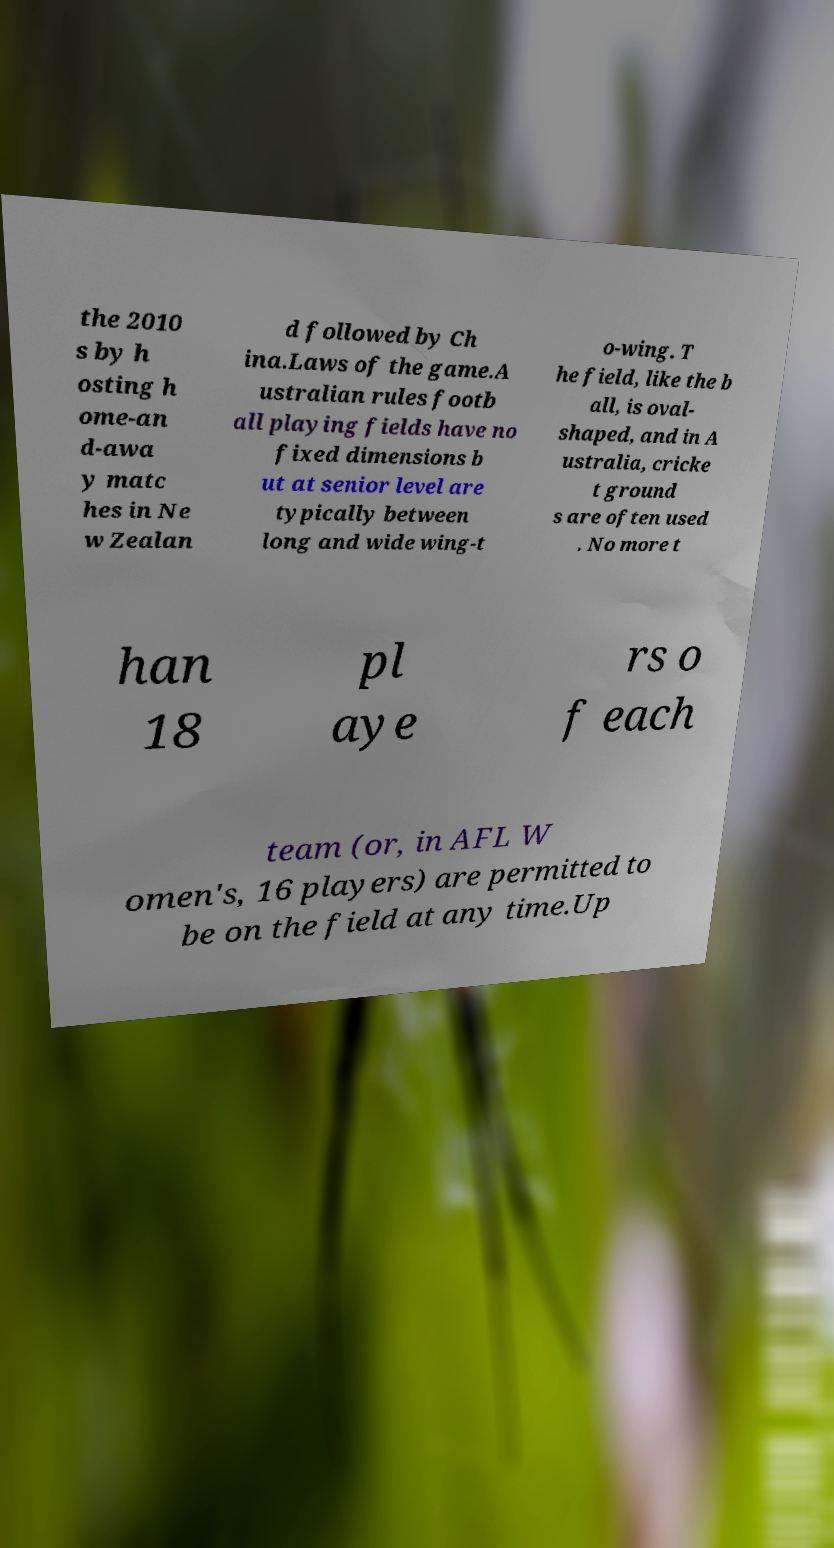Could you assist in decoding the text presented in this image and type it out clearly? the 2010 s by h osting h ome-an d-awa y matc hes in Ne w Zealan d followed by Ch ina.Laws of the game.A ustralian rules footb all playing fields have no fixed dimensions b ut at senior level are typically between long and wide wing-t o-wing. T he field, like the b all, is oval- shaped, and in A ustralia, cricke t ground s are often used . No more t han 18 pl aye rs o f each team (or, in AFL W omen's, 16 players) are permitted to be on the field at any time.Up 